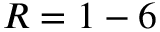Convert formula to latex. <formula><loc_0><loc_0><loc_500><loc_500>R = 1 - 6</formula> 